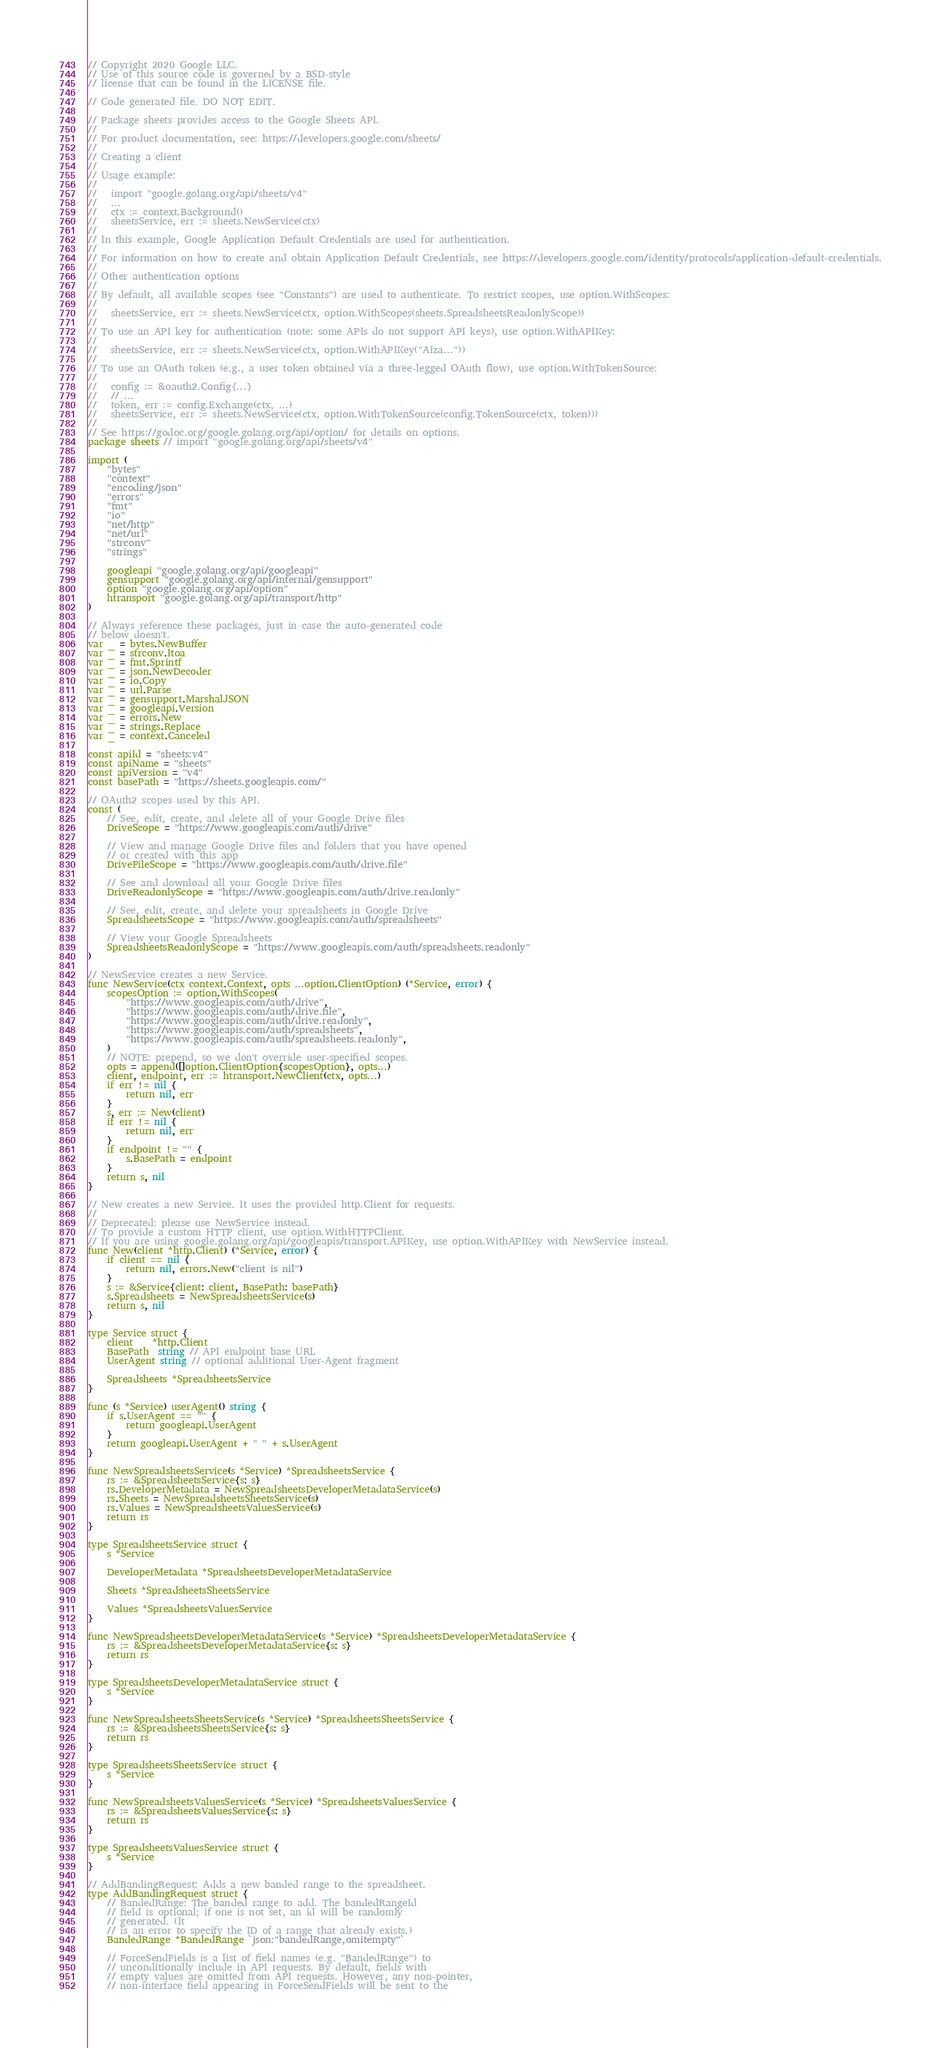<code> <loc_0><loc_0><loc_500><loc_500><_Go_>// Copyright 2020 Google LLC.
// Use of this source code is governed by a BSD-style
// license that can be found in the LICENSE file.

// Code generated file. DO NOT EDIT.

// Package sheets provides access to the Google Sheets API.
//
// For product documentation, see: https://developers.google.com/sheets/
//
// Creating a client
//
// Usage example:
//
//   import "google.golang.org/api/sheets/v4"
//   ...
//   ctx := context.Background()
//   sheetsService, err := sheets.NewService(ctx)
//
// In this example, Google Application Default Credentials are used for authentication.
//
// For information on how to create and obtain Application Default Credentials, see https://developers.google.com/identity/protocols/application-default-credentials.
//
// Other authentication options
//
// By default, all available scopes (see "Constants") are used to authenticate. To restrict scopes, use option.WithScopes:
//
//   sheetsService, err := sheets.NewService(ctx, option.WithScopes(sheets.SpreadsheetsReadonlyScope))
//
// To use an API key for authentication (note: some APIs do not support API keys), use option.WithAPIKey:
//
//   sheetsService, err := sheets.NewService(ctx, option.WithAPIKey("AIza..."))
//
// To use an OAuth token (e.g., a user token obtained via a three-legged OAuth flow), use option.WithTokenSource:
//
//   config := &oauth2.Config{...}
//   // ...
//   token, err := config.Exchange(ctx, ...)
//   sheetsService, err := sheets.NewService(ctx, option.WithTokenSource(config.TokenSource(ctx, token)))
//
// See https://godoc.org/google.golang.org/api/option/ for details on options.
package sheets // import "google.golang.org/api/sheets/v4"

import (
	"bytes"
	"context"
	"encoding/json"
	"errors"
	"fmt"
	"io"
	"net/http"
	"net/url"
	"strconv"
	"strings"

	googleapi "google.golang.org/api/googleapi"
	gensupport "google.golang.org/api/internal/gensupport"
	option "google.golang.org/api/option"
	htransport "google.golang.org/api/transport/http"
)

// Always reference these packages, just in case the auto-generated code
// below doesn't.
var _ = bytes.NewBuffer
var _ = strconv.Itoa
var _ = fmt.Sprintf
var _ = json.NewDecoder
var _ = io.Copy
var _ = url.Parse
var _ = gensupport.MarshalJSON
var _ = googleapi.Version
var _ = errors.New
var _ = strings.Replace
var _ = context.Canceled

const apiId = "sheets:v4"
const apiName = "sheets"
const apiVersion = "v4"
const basePath = "https://sheets.googleapis.com/"

// OAuth2 scopes used by this API.
const (
	// See, edit, create, and delete all of your Google Drive files
	DriveScope = "https://www.googleapis.com/auth/drive"

	// View and manage Google Drive files and folders that you have opened
	// or created with this app
	DriveFileScope = "https://www.googleapis.com/auth/drive.file"

	// See and download all your Google Drive files
	DriveReadonlyScope = "https://www.googleapis.com/auth/drive.readonly"

	// See, edit, create, and delete your spreadsheets in Google Drive
	SpreadsheetsScope = "https://www.googleapis.com/auth/spreadsheets"

	// View your Google Spreadsheets
	SpreadsheetsReadonlyScope = "https://www.googleapis.com/auth/spreadsheets.readonly"
)

// NewService creates a new Service.
func NewService(ctx context.Context, opts ...option.ClientOption) (*Service, error) {
	scopesOption := option.WithScopes(
		"https://www.googleapis.com/auth/drive",
		"https://www.googleapis.com/auth/drive.file",
		"https://www.googleapis.com/auth/drive.readonly",
		"https://www.googleapis.com/auth/spreadsheets",
		"https://www.googleapis.com/auth/spreadsheets.readonly",
	)
	// NOTE: prepend, so we don't override user-specified scopes.
	opts = append([]option.ClientOption{scopesOption}, opts...)
	client, endpoint, err := htransport.NewClient(ctx, opts...)
	if err != nil {
		return nil, err
	}
	s, err := New(client)
	if err != nil {
		return nil, err
	}
	if endpoint != "" {
		s.BasePath = endpoint
	}
	return s, nil
}

// New creates a new Service. It uses the provided http.Client for requests.
//
// Deprecated: please use NewService instead.
// To provide a custom HTTP client, use option.WithHTTPClient.
// If you are using google.golang.org/api/googleapis/transport.APIKey, use option.WithAPIKey with NewService instead.
func New(client *http.Client) (*Service, error) {
	if client == nil {
		return nil, errors.New("client is nil")
	}
	s := &Service{client: client, BasePath: basePath}
	s.Spreadsheets = NewSpreadsheetsService(s)
	return s, nil
}

type Service struct {
	client    *http.Client
	BasePath  string // API endpoint base URL
	UserAgent string // optional additional User-Agent fragment

	Spreadsheets *SpreadsheetsService
}

func (s *Service) userAgent() string {
	if s.UserAgent == "" {
		return googleapi.UserAgent
	}
	return googleapi.UserAgent + " " + s.UserAgent
}

func NewSpreadsheetsService(s *Service) *SpreadsheetsService {
	rs := &SpreadsheetsService{s: s}
	rs.DeveloperMetadata = NewSpreadsheetsDeveloperMetadataService(s)
	rs.Sheets = NewSpreadsheetsSheetsService(s)
	rs.Values = NewSpreadsheetsValuesService(s)
	return rs
}

type SpreadsheetsService struct {
	s *Service

	DeveloperMetadata *SpreadsheetsDeveloperMetadataService

	Sheets *SpreadsheetsSheetsService

	Values *SpreadsheetsValuesService
}

func NewSpreadsheetsDeveloperMetadataService(s *Service) *SpreadsheetsDeveloperMetadataService {
	rs := &SpreadsheetsDeveloperMetadataService{s: s}
	return rs
}

type SpreadsheetsDeveloperMetadataService struct {
	s *Service
}

func NewSpreadsheetsSheetsService(s *Service) *SpreadsheetsSheetsService {
	rs := &SpreadsheetsSheetsService{s: s}
	return rs
}

type SpreadsheetsSheetsService struct {
	s *Service
}

func NewSpreadsheetsValuesService(s *Service) *SpreadsheetsValuesService {
	rs := &SpreadsheetsValuesService{s: s}
	return rs
}

type SpreadsheetsValuesService struct {
	s *Service
}

// AddBandingRequest: Adds a new banded range to the spreadsheet.
type AddBandingRequest struct {
	// BandedRange: The banded range to add. The bandedRangeId
	// field is optional; if one is not set, an id will be randomly
	// generated. (It
	// is an error to specify the ID of a range that already exists.)
	BandedRange *BandedRange `json:"bandedRange,omitempty"`

	// ForceSendFields is a list of field names (e.g. "BandedRange") to
	// unconditionally include in API requests. By default, fields with
	// empty values are omitted from API requests. However, any non-pointer,
	// non-interface field appearing in ForceSendFields will be sent to the</code> 